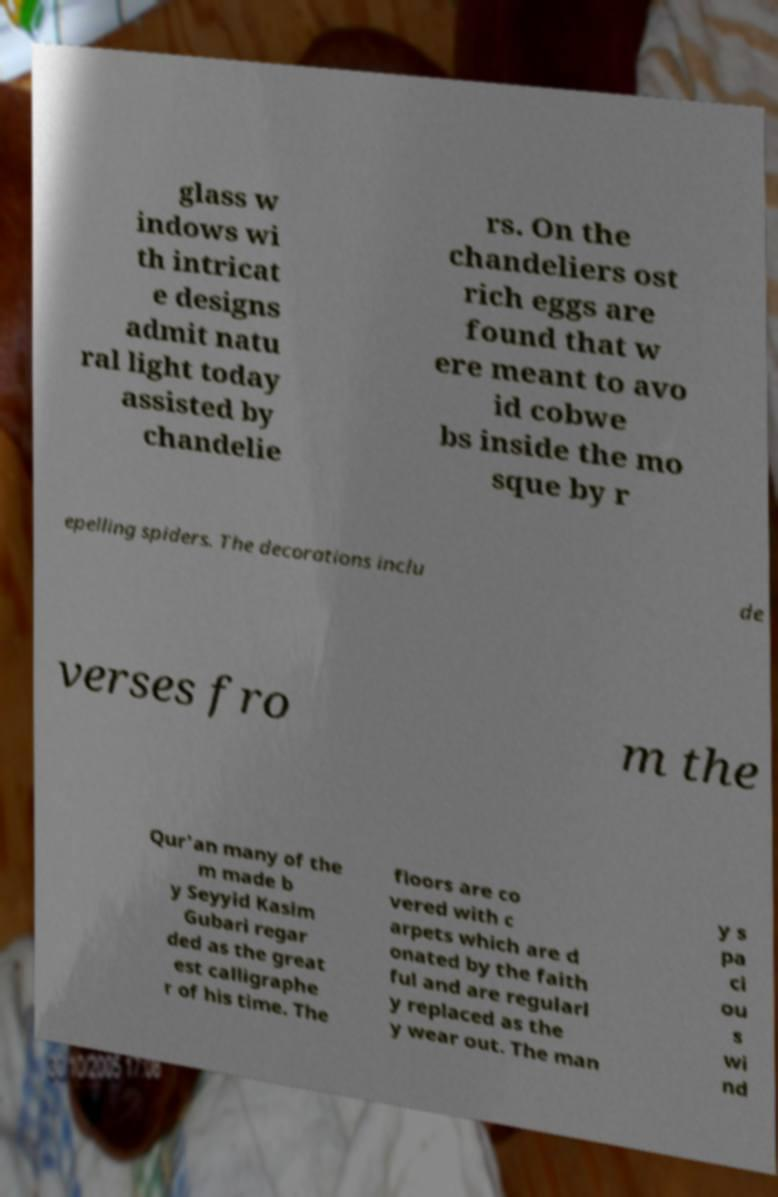Could you assist in decoding the text presented in this image and type it out clearly? glass w indows wi th intricat e designs admit natu ral light today assisted by chandelie rs. On the chandeliers ost rich eggs are found that w ere meant to avo id cobwe bs inside the mo sque by r epelling spiders. The decorations inclu de verses fro m the Qur'an many of the m made b y Seyyid Kasim Gubari regar ded as the great est calligraphe r of his time. The floors are co vered with c arpets which are d onated by the faith ful and are regularl y replaced as the y wear out. The man y s pa ci ou s wi nd 